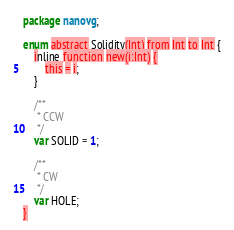Convert code to text. <code><loc_0><loc_0><loc_500><loc_500><_Haxe_>package nanovg;

enum abstract Solidity(Int) from Int to Int {
    inline function new(i:Int) {
        this = i;
    }

    /**
     * CCW
     */
    var SOLID = 1;

    /**
     * CW
     */
    var HOLE;
}</code> 